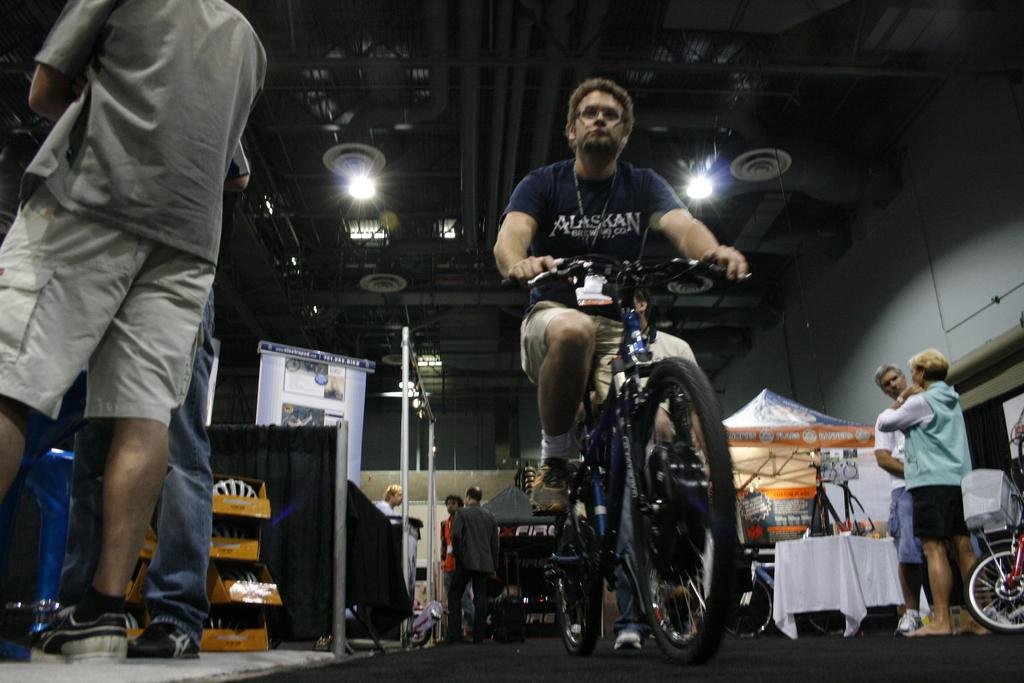What is the man in the image doing? The man is sitting on a cycle in the image. Are there any other people visible in the image? Yes, there are people standing in the image. What type of furniture is present in the image? There is a table in the image. What decorative element is present in the image? There is a banner in the image. What can be seen providing illumination in the image? There are lights in the image. Can you identify another cycle in the image? Yes, there is another cycle in the image. What type of summer attraction is depicted in the image? There is no specific summer attraction mentioned or depicted in the image. 